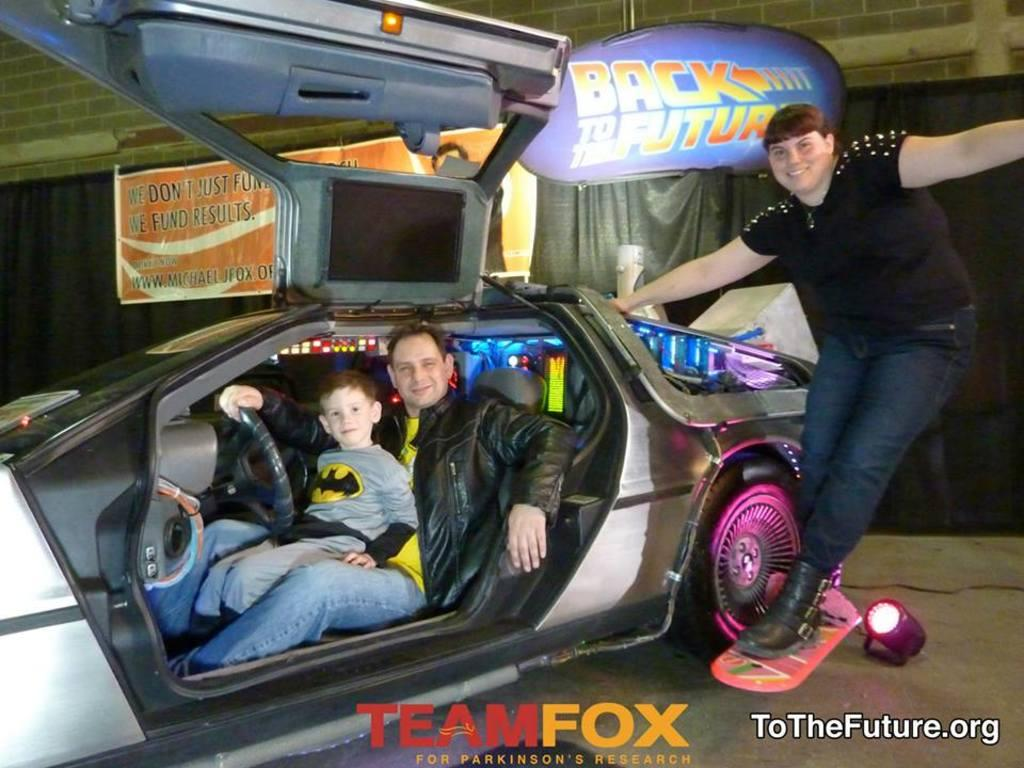Who is present in the image? There is a man, a boy, and a woman in the image. What are they doing in the image? The man, the boy, and the woman are all in a car. What is the mood of the people in the image? The man, the boy, and the woman are all smiling, which suggests a positive mood. What type of worm can be seen crawling on the car in the image? There is no worm present in the image; it only features a man, a boy, and a woman in a car. What joke is the man telling the boy in the image? There is no indication of a joke being told in the image; the people are simply smiling. 